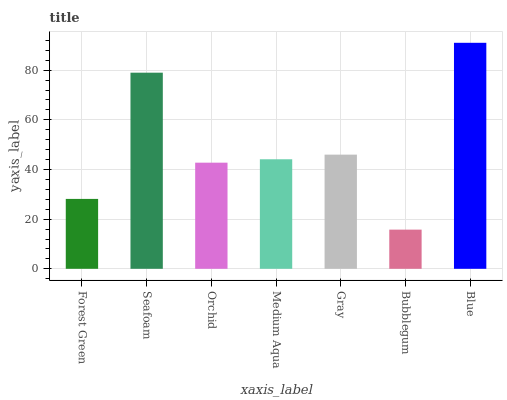Is Bubblegum the minimum?
Answer yes or no. Yes. Is Blue the maximum?
Answer yes or no. Yes. Is Seafoam the minimum?
Answer yes or no. No. Is Seafoam the maximum?
Answer yes or no. No. Is Seafoam greater than Forest Green?
Answer yes or no. Yes. Is Forest Green less than Seafoam?
Answer yes or no. Yes. Is Forest Green greater than Seafoam?
Answer yes or no. No. Is Seafoam less than Forest Green?
Answer yes or no. No. Is Medium Aqua the high median?
Answer yes or no. Yes. Is Medium Aqua the low median?
Answer yes or no. Yes. Is Bubblegum the high median?
Answer yes or no. No. Is Bubblegum the low median?
Answer yes or no. No. 